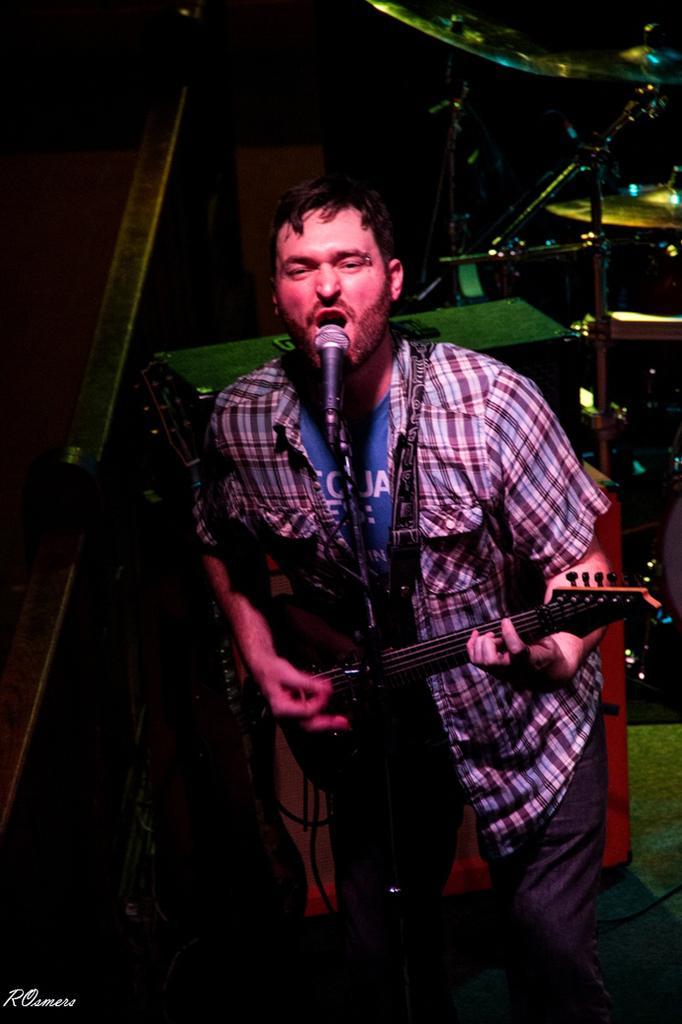How would you summarize this image in a sentence or two? In this image we have a man standing and playing a guitar by singing a song in the micro phone and at the background we have cymbals and drums. 